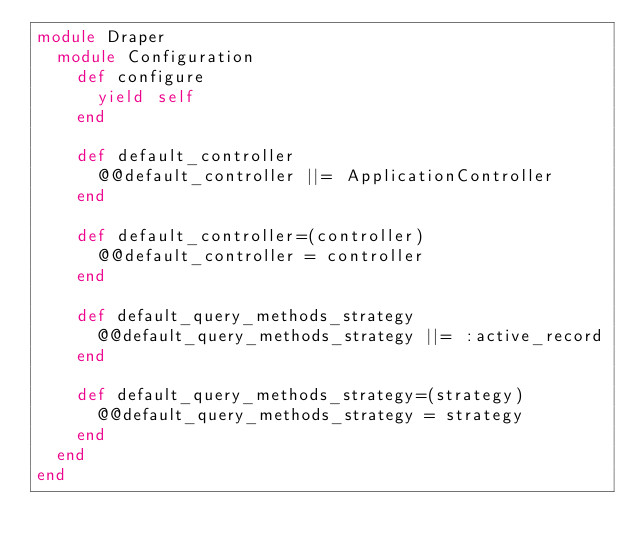<code> <loc_0><loc_0><loc_500><loc_500><_Ruby_>module Draper
  module Configuration
    def configure
      yield self
    end

    def default_controller
      @@default_controller ||= ApplicationController
    end

    def default_controller=(controller)
      @@default_controller = controller
    end

    def default_query_methods_strategy
      @@default_query_methods_strategy ||= :active_record
    end

    def default_query_methods_strategy=(strategy)
      @@default_query_methods_strategy = strategy
    end
  end
end
</code> 